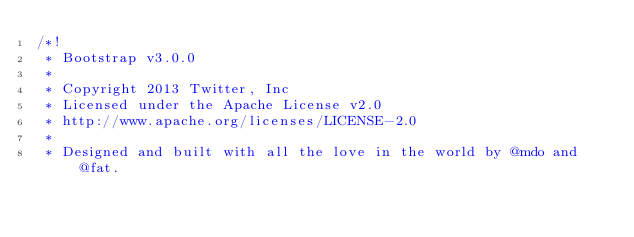<code> <loc_0><loc_0><loc_500><loc_500><_CSS_>/*!
 * Bootstrap v3.0.0
 *
 * Copyright 2013 Twitter, Inc
 * Licensed under the Apache License v2.0
 * http://www.apache.org/licenses/LICENSE-2.0
 *
 * Designed and built with all the love in the world by @mdo and @fat.</code> 